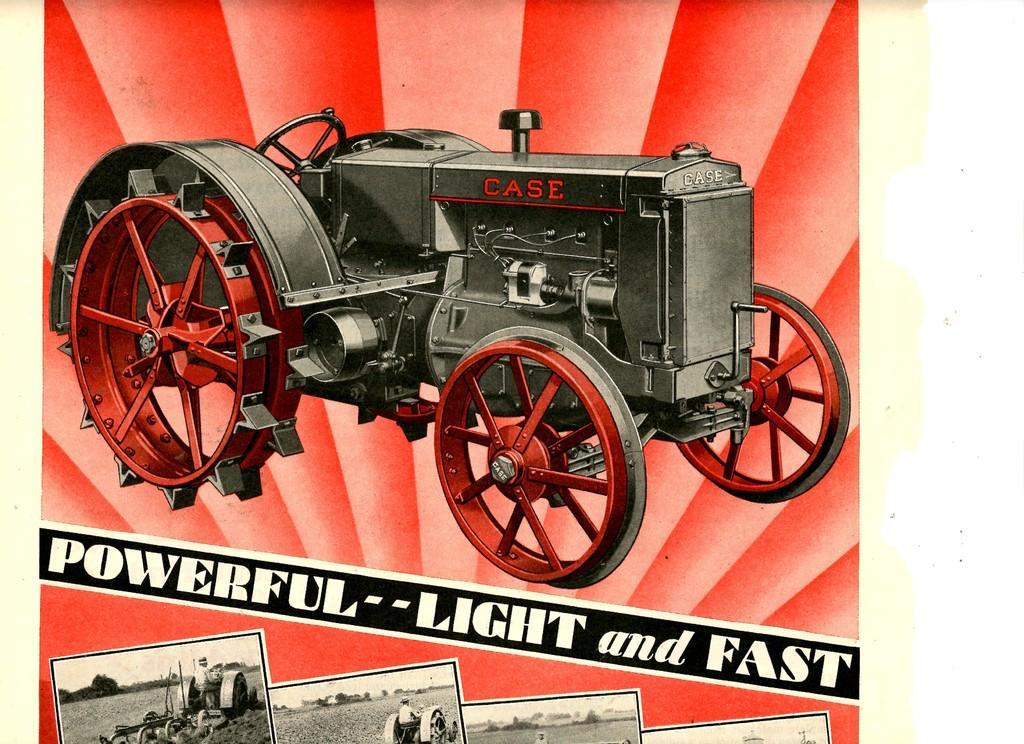Describe this image in one or two sentences. This picture shows a advertisement poster. We see a tractor and college of few pictures at the bottom and we see text on it. 